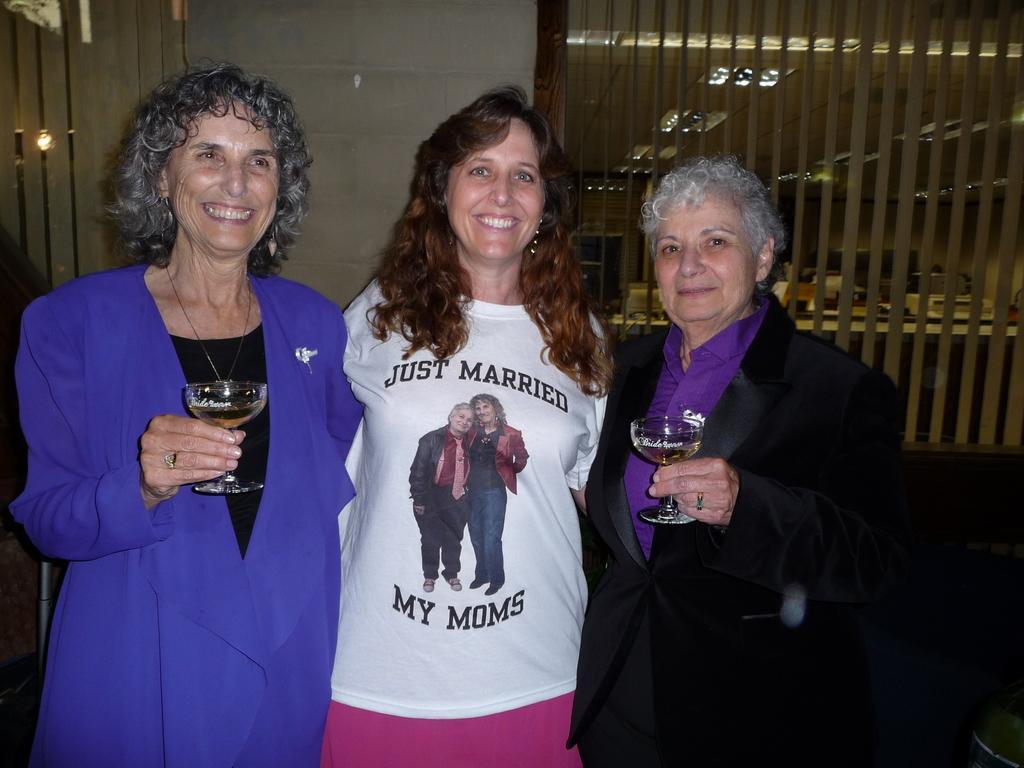In one or two sentences, can you explain what this image depicts? In the middle of the image few people are standing and smiling and holding glasses. Behind them there is wall. Top of the image there is roof and lights. 